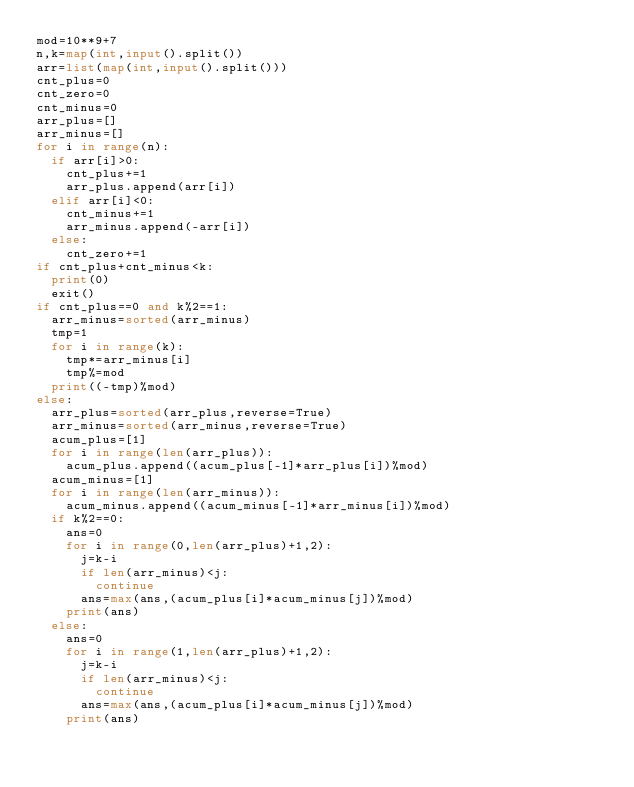<code> <loc_0><loc_0><loc_500><loc_500><_Python_>mod=10**9+7
n,k=map(int,input().split())
arr=list(map(int,input().split()))
cnt_plus=0
cnt_zero=0
cnt_minus=0
arr_plus=[]
arr_minus=[]
for i in range(n):
  if arr[i]>0:
    cnt_plus+=1
    arr_plus.append(arr[i])
  elif arr[i]<0:
    cnt_minus+=1
    arr_minus.append(-arr[i])
  else:
    cnt_zero+=1
if cnt_plus+cnt_minus<k:
  print(0)
  exit()
if cnt_plus==0 and k%2==1:
  arr_minus=sorted(arr_minus)
  tmp=1
  for i in range(k):
    tmp*=arr_minus[i]
    tmp%=mod
  print((-tmp)%mod)
else:
  arr_plus=sorted(arr_plus,reverse=True)
  arr_minus=sorted(arr_minus,reverse=True)
  acum_plus=[1]
  for i in range(len(arr_plus)):
    acum_plus.append((acum_plus[-1]*arr_plus[i])%mod)
  acum_minus=[1]  
  for i in range(len(arr_minus)):
    acum_minus.append((acum_minus[-1]*arr_minus[i])%mod)  
  if k%2==0:
    ans=0
    for i in range(0,len(arr_plus)+1,2):
      j=k-i
      if len(arr_minus)<j:
        continue
      ans=max(ans,(acum_plus[i]*acum_minus[j])%mod)
    print(ans)
  else:
    ans=0
    for i in range(1,len(arr_plus)+1,2):
      j=k-i
      if len(arr_minus)<j:
        continue
      ans=max(ans,(acum_plus[i]*acum_minus[j])%mod)
    print(ans)</code> 